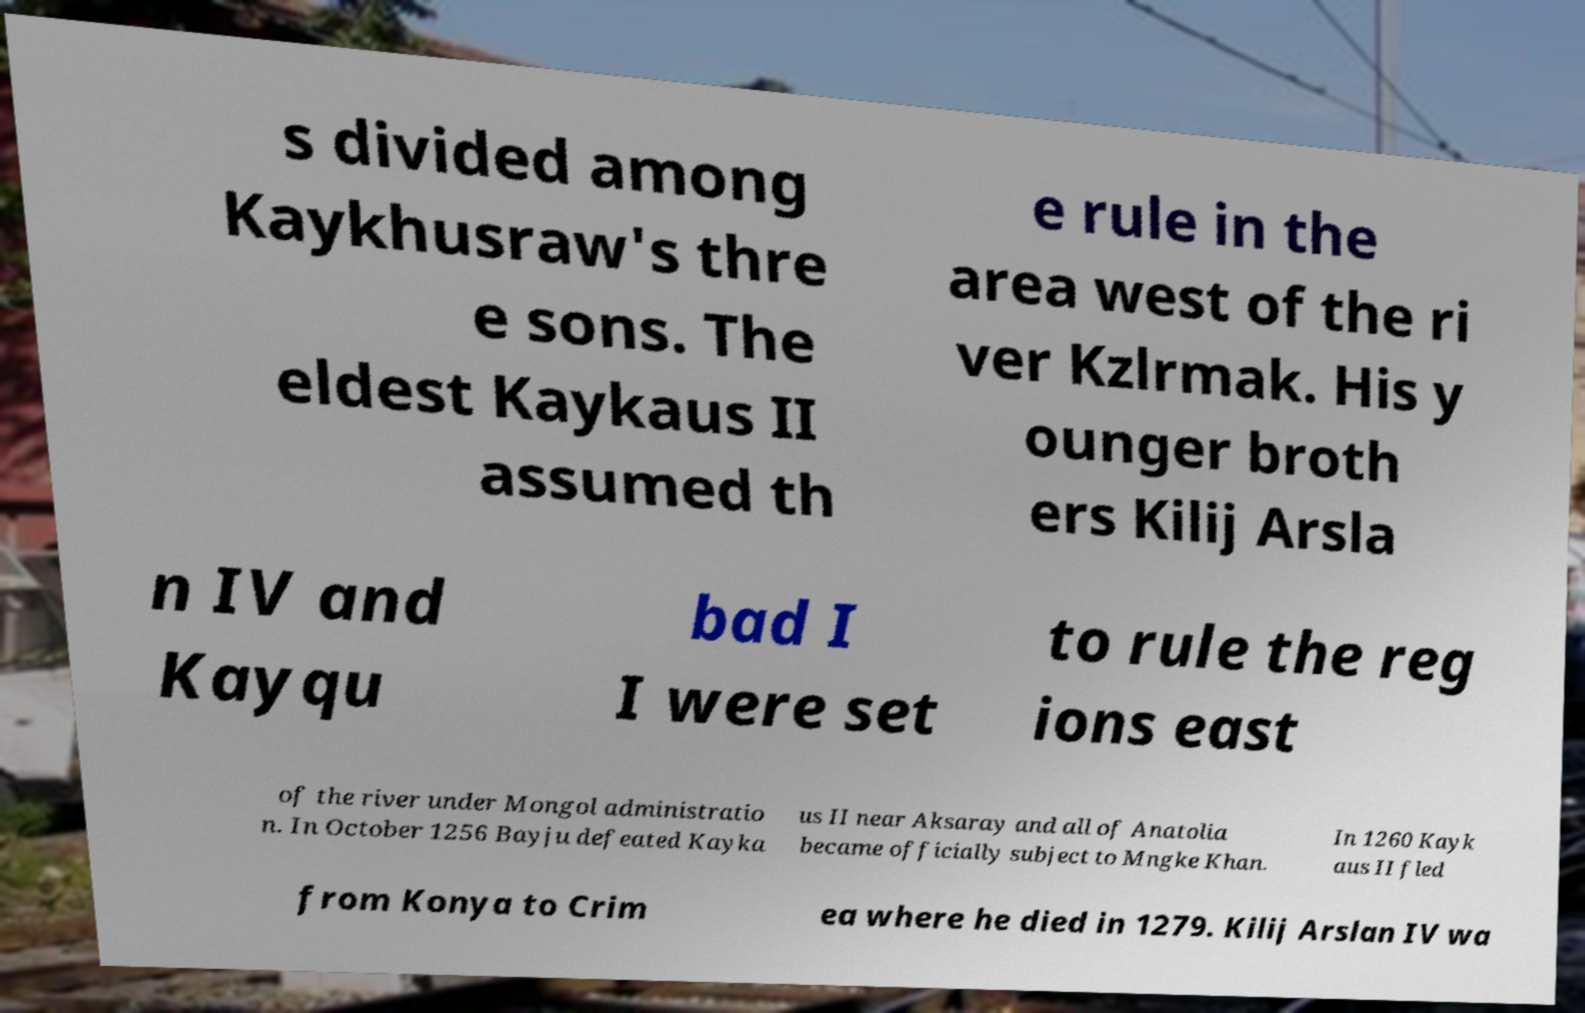Could you assist in decoding the text presented in this image and type it out clearly? s divided among Kaykhusraw's thre e sons. The eldest Kaykaus II assumed th e rule in the area west of the ri ver Kzlrmak. His y ounger broth ers Kilij Arsla n IV and Kayqu bad I I were set to rule the reg ions east of the river under Mongol administratio n. In October 1256 Bayju defeated Kayka us II near Aksaray and all of Anatolia became officially subject to Mngke Khan. In 1260 Kayk aus II fled from Konya to Crim ea where he died in 1279. Kilij Arslan IV wa 